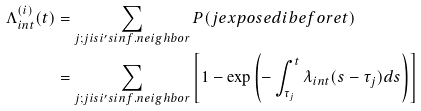Convert formula to latex. <formula><loc_0><loc_0><loc_500><loc_500>\Lambda _ { i n t } ^ { ( i ) } ( t ) & = \sum _ { j ; j i s i ^ { \prime } s i n f . n e i g h b o r } P ( j e x p o s e d i b e f o r e t ) \\ & = \sum _ { j ; j i s i ^ { \prime } s i n f . n e i g h b o r } \left [ 1 - \exp \left ( - \int _ { \tau _ { j } } ^ { t } \lambda _ { i n t } ( s - \tau _ { j } ) d s \right ) \right ]</formula> 